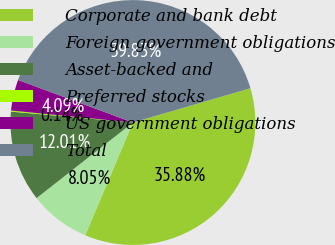<chart> <loc_0><loc_0><loc_500><loc_500><pie_chart><fcel>Corporate and bank debt<fcel>Foreign government obligations<fcel>Asset-backed and<fcel>Preferred stocks<fcel>US government obligations<fcel>Total<nl><fcel>35.88%<fcel>8.05%<fcel>12.01%<fcel>0.14%<fcel>4.09%<fcel>39.83%<nl></chart> 